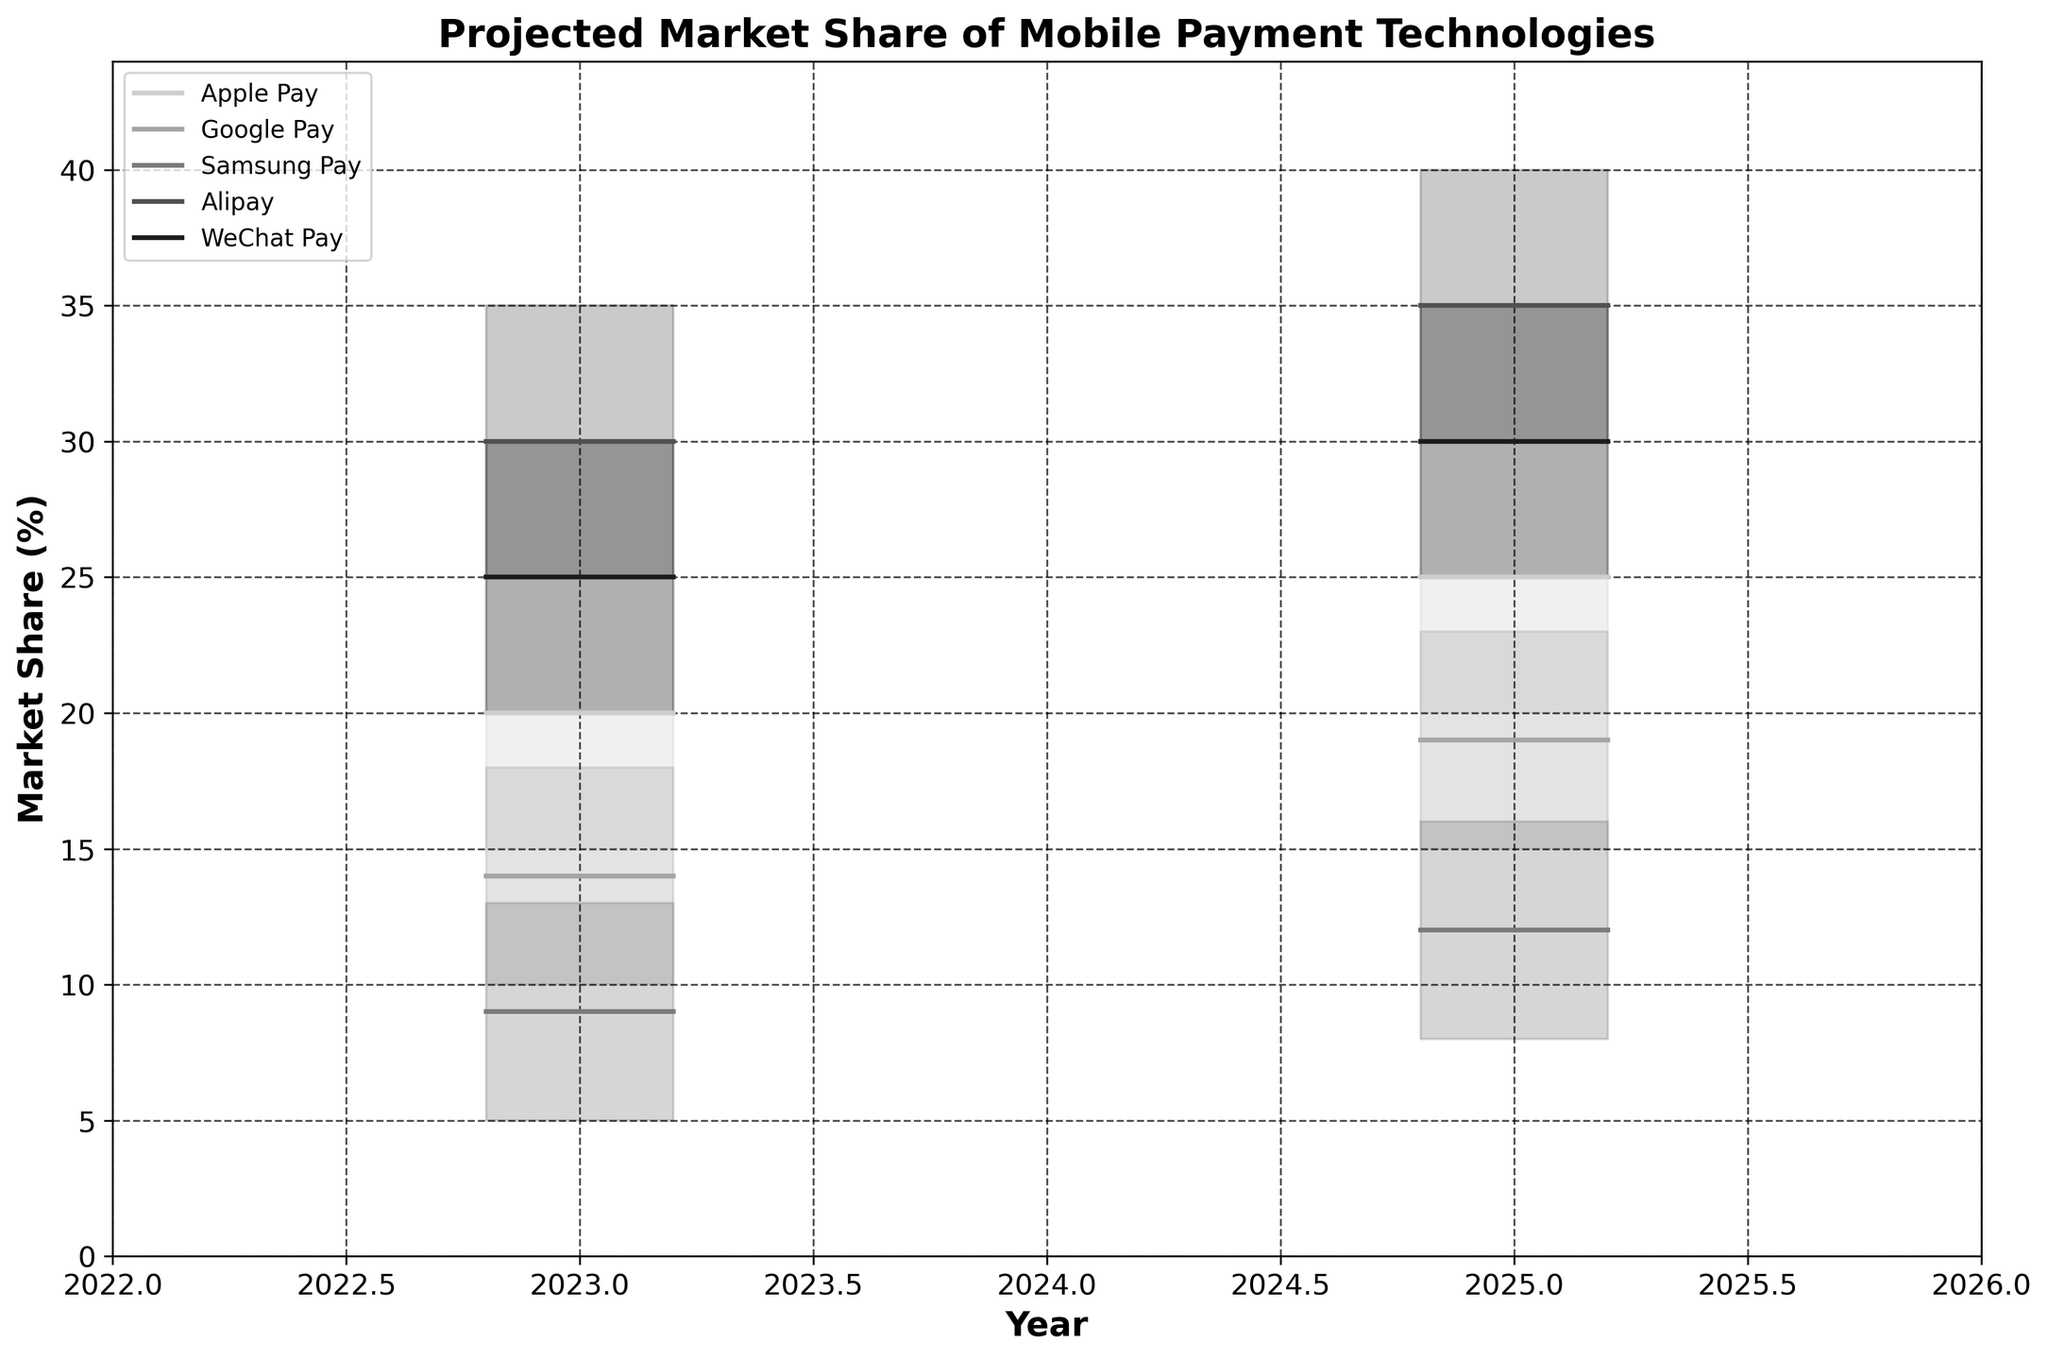What is the projected market share range for Apple Pay in North America in 2023? The fan chart shows the projected market share for Apple Pay in North America in 2023 as a range from the lowest to highest values indicated. These are 15% (Low) to 25% (High).
Answer: 15% to 25% Which mobile payment technology has the highest mid-value projection in Asia-Pacific for 2025? To determine this, we compare the mid-values of Alipay, WeChat Pay, and Apple Pay in Asia-Pacific for 2025 from the data. Alipay has a mid-value of 35%, WeChat Pay has a mid-value of 30%, and Apple Pay has a mid-value of 12%. Alipay has the highest mid-value.
Answer: Alipay Among Apple Pay, Google Pay, and Samsung Pay, which technology shows the largest projected market share increase in North America from 2023 to 2025? We compare the projected mid-values in North America for these technologies between 2023 and 2025. Apple Pay goes from 20% to 25%, an increase of 5%. Google Pay goes from 14% to 19%, an increase of 5%. Samsung Pay goes from 9% to 12%, an increase of 3%. Both Apple Pay and Google Pay have the largest increase.
Answer: Apple Pay and Google Pay What is the projected average high value for Google Pay across all regions in 2023? Summing the high values for Google Pay across all regions in 2023: North America (18%), Europe (16%), and Asia-Pacific (N/A since it's not listed). Average is calculated as (18 + 16) / 2 = 17%.
Answer: 17% Which region shows the highest range of market share projections for any mobile payment technology in 2025, and which technology shows this range? Comparing the range from low to high values across all regions and technologies in 2025: North America (Apple Pay: 20-30 = 10%), Google Pay (15-23 = 8%), Samsung Pay (8-16 = 8%); Europe Apple Pay (17-25 = 8%), Google Pay (13-21 = 8%), Samsung Pay (6-14 = 8%); Asia-Pacific Alipay (30-40 = 10%), WeChat Pay (25-35 = 10%), Apple Pay (8-16 = 8%). The largest range is in Asia-Pacific with Alipay and WeChat Pay having a range of 10%.
Answer: Asia-Pacific, Alipay and WeChat Pay How do the market share projections for mobile payment technologies differ between Europe and North America for 2025? Compare the mid-values for Apple Pay, Google Pay, and Samsung Pay in both regions for 2025. In Europe, the mid-values are 21%, 17%, and 10% respectively. In North America, they are 25%, 19%, and 12% respectively. North America's values are higher than Europe's across the board.
Answer: North America's projections are higher Which technology is projected to hold the lowest market share in Europe in 2023? From the data, comparing mid-values of Apple Pay (16%), Google Pay (12%), and Samsung Pay (7%) in Europe for 2023, Samsung Pay holds the lowest market share.
Answer: Samsung Pay 